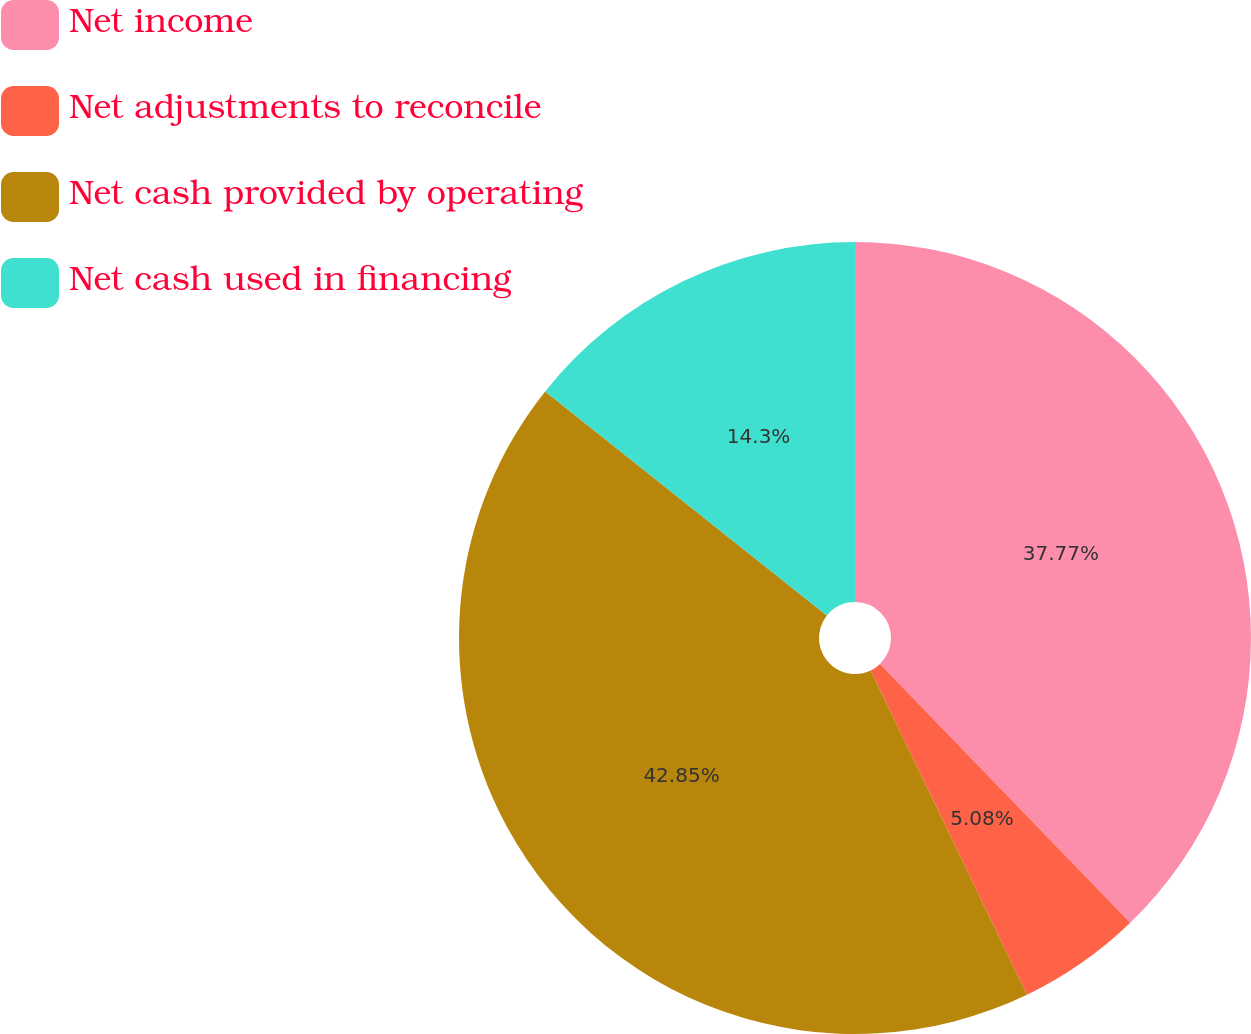<chart> <loc_0><loc_0><loc_500><loc_500><pie_chart><fcel>Net income<fcel>Net adjustments to reconcile<fcel>Net cash provided by operating<fcel>Net cash used in financing<nl><fcel>37.77%<fcel>5.08%<fcel>42.85%<fcel>14.3%<nl></chart> 